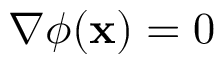<formula> <loc_0><loc_0><loc_500><loc_500>\nabla \phi ( x ) = 0</formula> 